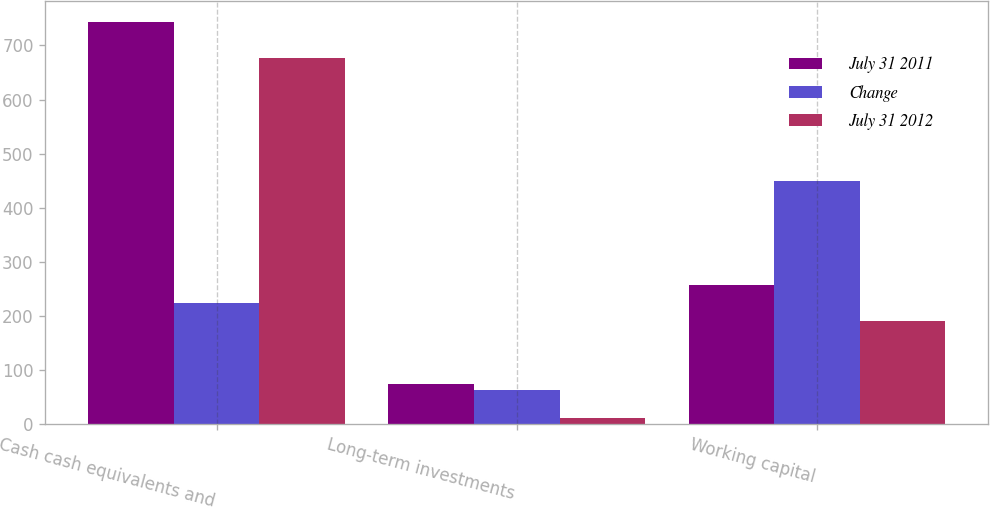<chart> <loc_0><loc_0><loc_500><loc_500><stacked_bar_chart><ecel><fcel>Cash cash equivalents and<fcel>Long-term investments<fcel>Working capital<nl><fcel>July 31 2011<fcel>744<fcel>75<fcel>258<nl><fcel>Change<fcel>224.5<fcel>63<fcel>449<nl><fcel>July 31 2012<fcel>677<fcel>12<fcel>191<nl></chart> 